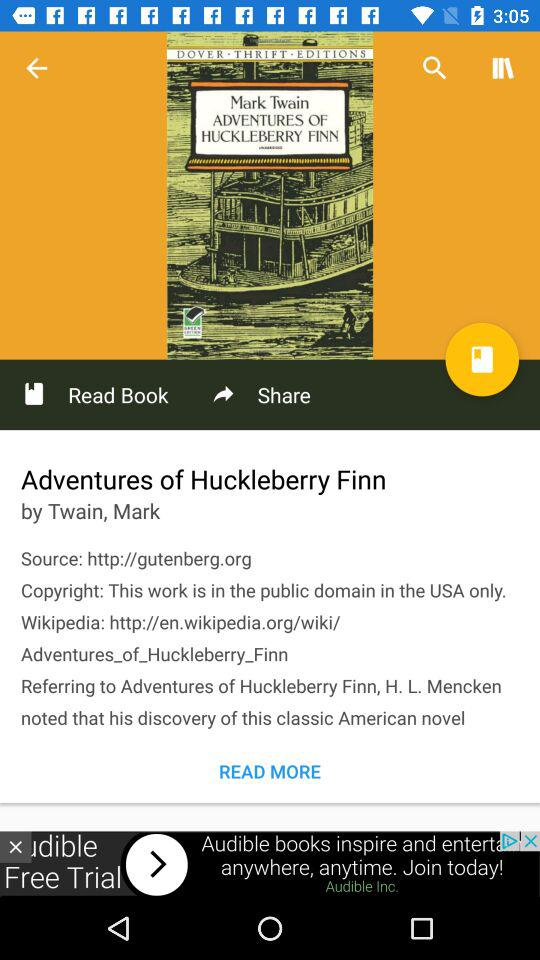Which country has the copyright to the novel Huckleberry Finn? The country has the copyright to the novel Huckleberry Finn in the USA. 